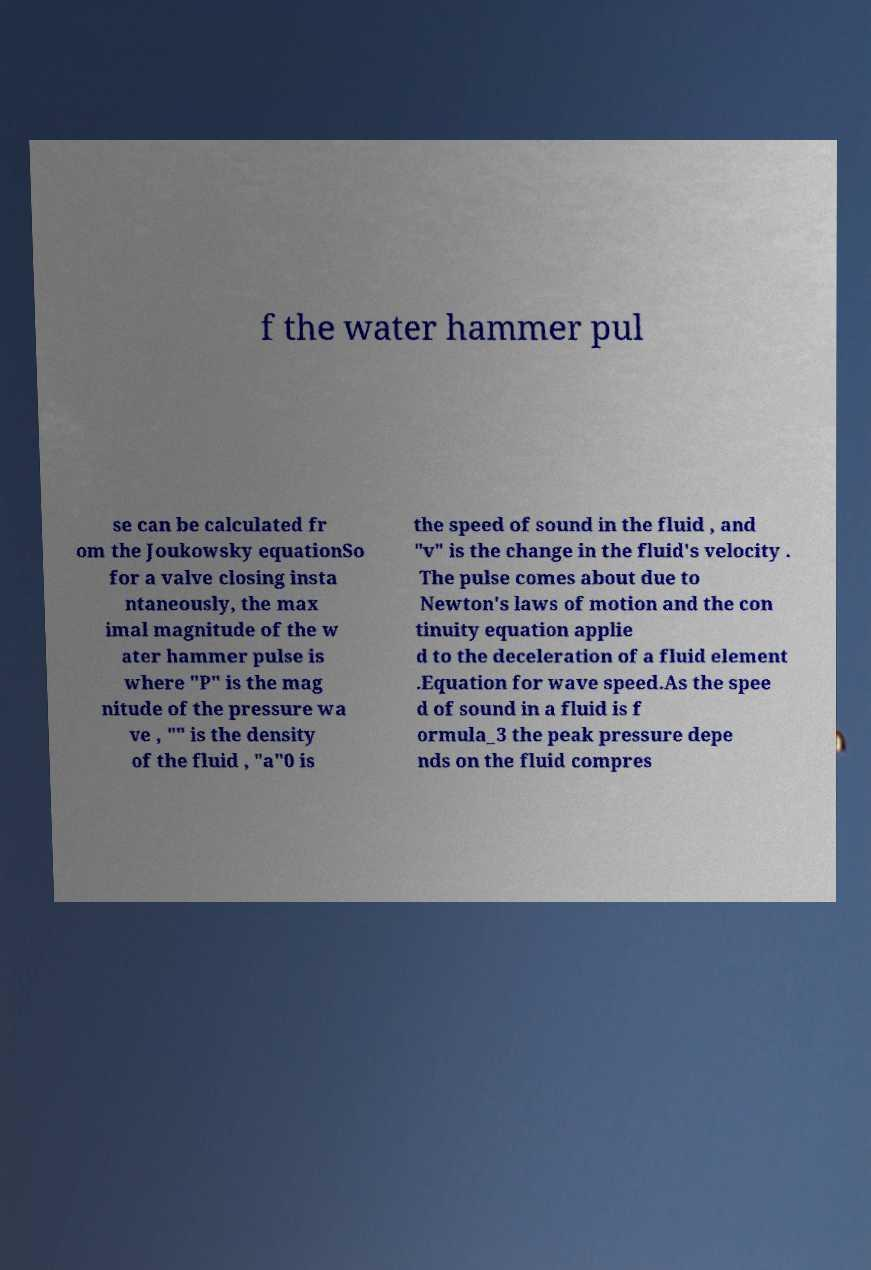What messages or text are displayed in this image? I need them in a readable, typed format. f the water hammer pul se can be calculated fr om the Joukowsky equationSo for a valve closing insta ntaneously, the max imal magnitude of the w ater hammer pulse is where "P" is the mag nitude of the pressure wa ve , "" is the density of the fluid , "a"0 is the speed of sound in the fluid , and "v" is the change in the fluid's velocity . The pulse comes about due to Newton's laws of motion and the con tinuity equation applie d to the deceleration of a fluid element .Equation for wave speed.As the spee d of sound in a fluid is f ormula_3 the peak pressure depe nds on the fluid compres 